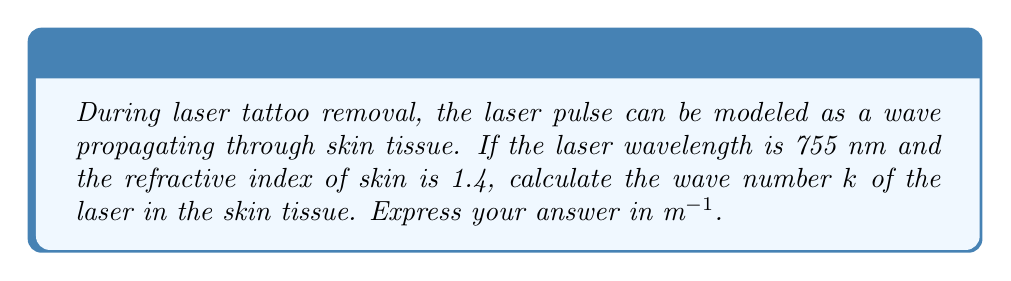Provide a solution to this math problem. To solve this problem, we'll follow these steps:

1) The wave number $k$ is related to the wavelength $\lambda$ and refractive index $n$ by the formula:

   $$k = \frac{2\pi n}{\lambda}$$

2) We're given:
   - Wavelength in air: $\lambda_0 = 755 \text{ nm} = 755 \times 10^{-9} \text{ m}$
   - Refractive index of skin: $n = 1.4$

3) First, we need to calculate the wavelength in the skin tissue:

   $$\lambda = \frac{\lambda_0}{n} = \frac{755 \times 10^{-9}}{1.4} \text{ m}$$

4) Now, let's substitute this into our wave number formula:

   $$k = \frac{2\pi n}{\lambda} = \frac{2\pi \times 1.4}{\frac{755 \times 10^{-9}}{1.4}} \text{ m}^{-1}$$

5) Simplify:
   
   $$k = \frac{2\pi \times (1.4)^2}{755 \times 10^{-9}} \text{ m}^{-1}$$

6) Calculate:
   
   $$k \approx 11,655,629 \text{ m}^{-1}$$

7) Round to the nearest whole number:

   $$k \approx 11,655,629 \text{ m}^{-1}$$
Answer: $11,655,629 \text{ m}^{-1}$ 